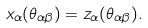<formula> <loc_0><loc_0><loc_500><loc_500>x _ { \alpha } ( \theta _ { \alpha \beta } ) = z _ { \alpha } ( \theta _ { \alpha \beta } ) .</formula> 